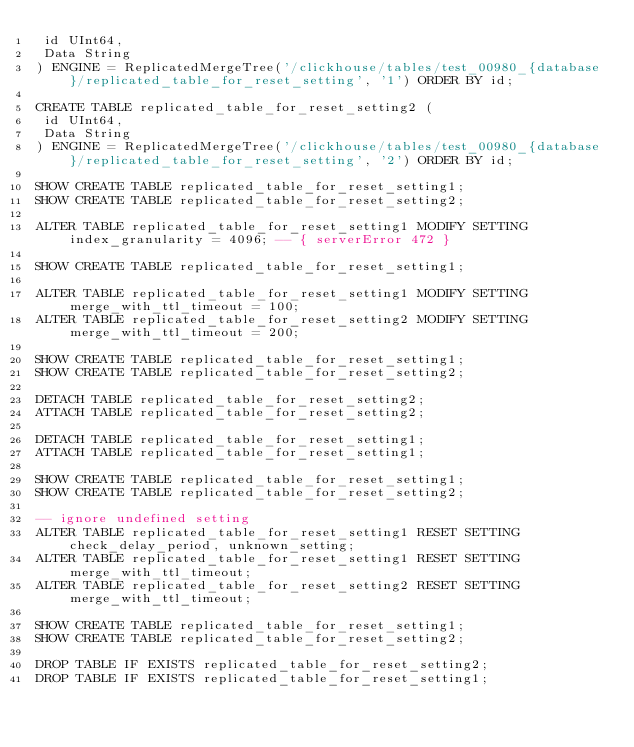<code> <loc_0><loc_0><loc_500><loc_500><_SQL_> id UInt64,
 Data String
) ENGINE = ReplicatedMergeTree('/clickhouse/tables/test_00980_{database}/replicated_table_for_reset_setting', '1') ORDER BY id;

CREATE TABLE replicated_table_for_reset_setting2 (
 id UInt64,
 Data String
) ENGINE = ReplicatedMergeTree('/clickhouse/tables/test_00980_{database}/replicated_table_for_reset_setting', '2') ORDER BY id;

SHOW CREATE TABLE replicated_table_for_reset_setting1;
SHOW CREATE TABLE replicated_table_for_reset_setting2;

ALTER TABLE replicated_table_for_reset_setting1 MODIFY SETTING index_granularity = 4096; -- { serverError 472 }

SHOW CREATE TABLE replicated_table_for_reset_setting1;

ALTER TABLE replicated_table_for_reset_setting1 MODIFY SETTING merge_with_ttl_timeout = 100;
ALTER TABLE replicated_table_for_reset_setting2 MODIFY SETTING merge_with_ttl_timeout = 200;

SHOW CREATE TABLE replicated_table_for_reset_setting1;
SHOW CREATE TABLE replicated_table_for_reset_setting2;

DETACH TABLE replicated_table_for_reset_setting2;
ATTACH TABLE replicated_table_for_reset_setting2;

DETACH TABLE replicated_table_for_reset_setting1;
ATTACH TABLE replicated_table_for_reset_setting1;

SHOW CREATE TABLE replicated_table_for_reset_setting1;
SHOW CREATE TABLE replicated_table_for_reset_setting2;

-- ignore undefined setting
ALTER TABLE replicated_table_for_reset_setting1 RESET SETTING check_delay_period, unknown_setting;
ALTER TABLE replicated_table_for_reset_setting1 RESET SETTING merge_with_ttl_timeout;
ALTER TABLE replicated_table_for_reset_setting2 RESET SETTING merge_with_ttl_timeout;

SHOW CREATE TABLE replicated_table_for_reset_setting1;
SHOW CREATE TABLE replicated_table_for_reset_setting2;

DROP TABLE IF EXISTS replicated_table_for_reset_setting2;
DROP TABLE IF EXISTS replicated_table_for_reset_setting1;
</code> 